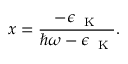Convert formula to latex. <formula><loc_0><loc_0><loc_500><loc_500>x = \frac { - \epsilon _ { K } } { \hbar { \omega } - \epsilon _ { K } } .</formula> 